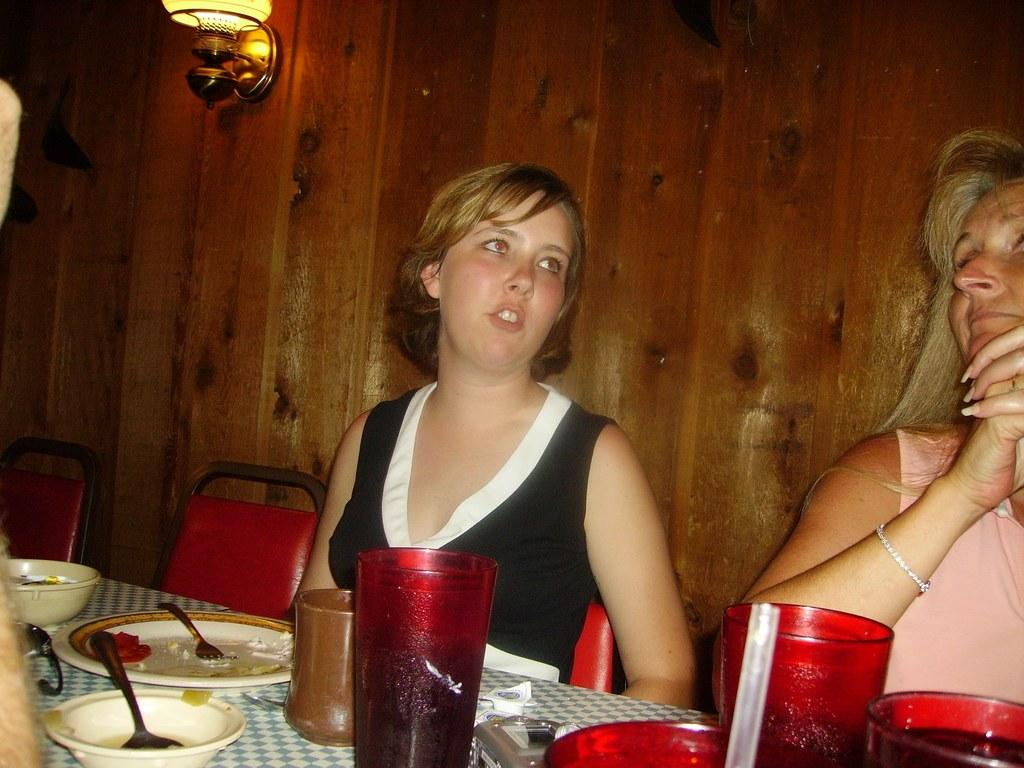How many people are sitting in the image? There are two persons sitting on chairs in the image. What is present on the table in the image? There is a glass, a bottle, a plate, a bowl, and a spoon on the table in the image. What might the people be using the spoon for? The spoon could be used for eating or serving food from the plate or bowl on the table. What type of crib is visible in the image? There is no crib present in the image. What role does the grandfather play in the image? There is no grandfather depicted in the image. Is the judge presiding over a case in the image? There is no judge or any legal proceedings depicted in the image. 